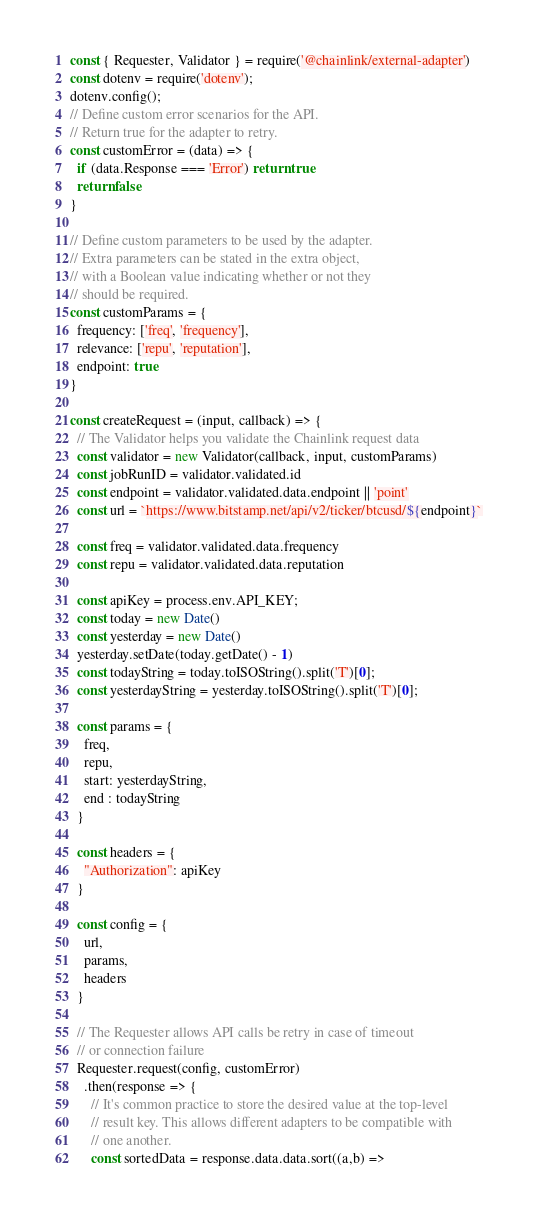<code> <loc_0><loc_0><loc_500><loc_500><_JavaScript_>const { Requester, Validator } = require('@chainlink/external-adapter')
const dotenv = require('dotenv');
dotenv.config();
// Define custom error scenarios for the API.
// Return true for the adapter to retry.
const customError = (data) => {
  if (data.Response === 'Error') return true
  return false
}

// Define custom parameters to be used by the adapter.
// Extra parameters can be stated in the extra object,
// with a Boolean value indicating whether or not they
// should be required.
const customParams = {
  frequency: ['freq', 'frequency'],
  relevance: ['repu', 'reputation'],
  endpoint: true
}

const createRequest = (input, callback) => {
  // The Validator helps you validate the Chainlink request data
  const validator = new Validator(callback, input, customParams)
  const jobRunID = validator.validated.id
  const endpoint = validator.validated.data.endpoint || 'point'
  const url = `https://www.bitstamp.net/api/v2/ticker/btcusd/${endpoint}`

  const freq = validator.validated.data.frequency
  const repu = validator.validated.data.reputation

  const apiKey = process.env.API_KEY;
  const today = new Date()
  const yesterday = new Date()
  yesterday.setDate(today.getDate() - 1)
  const todayString = today.toISOString().split('T')[0];
  const yesterdayString = yesterday.toISOString().split('T')[0];

  const params = {
    freq,
    repu,
    start: yesterdayString,
    end : todayString
  }

  const headers = {
    "Authorization": apiKey
  }

  const config = {
    url,
    params,
    headers
  }

  // The Requester allows API calls be retry in case of timeout
  // or connection failure
  Requester.request(config, customError)
    .then(response => {
      // It's common practice to store the desired value at the top-level
      // result key. This allows different adapters to be compatible with
      // one another.
      const sortedData = response.data.data.sort((a,b) => </code> 